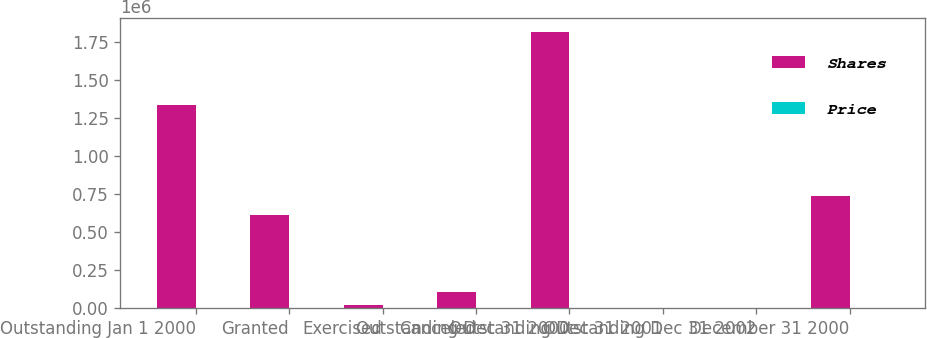Convert chart to OTSL. <chart><loc_0><loc_0><loc_500><loc_500><stacked_bar_chart><ecel><fcel>Outstanding Jan 1 2000<fcel>Granted<fcel>Exercised<fcel>Canceled<fcel>Outstanding Dec 31 2000<fcel>Outstanding Dec 31 2001<fcel>Outstanding Dec 31 2002<fcel>December 31 2000<nl><fcel>Shares<fcel>1.33881e+06<fcel>609900<fcel>21725<fcel>106050<fcel>1.82094e+06<fcel>38.31<fcel>38.31<fcel>736462<nl><fcel>Price<fcel>38.51<fcel>30.27<fcel>16.66<fcel>38.11<fcel>34.1<fcel>31.96<fcel>31.64<fcel>32.52<nl></chart> 